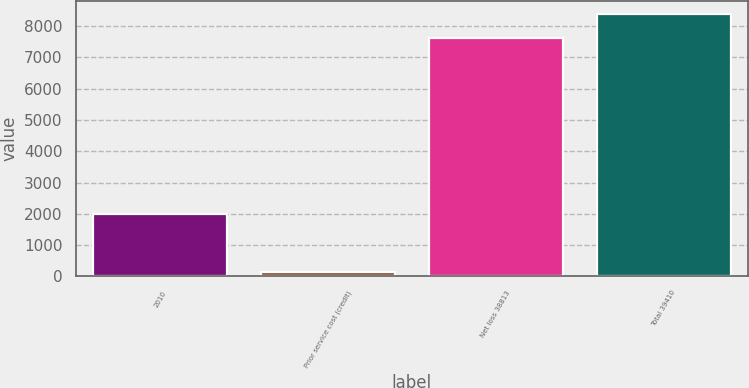Convert chart. <chart><loc_0><loc_0><loc_500><loc_500><bar_chart><fcel>2010<fcel>Prior service cost (credit)<fcel>Net loss 38813<fcel>Total 39410<nl><fcel>2010<fcel>131<fcel>7629<fcel>8391.9<nl></chart> 